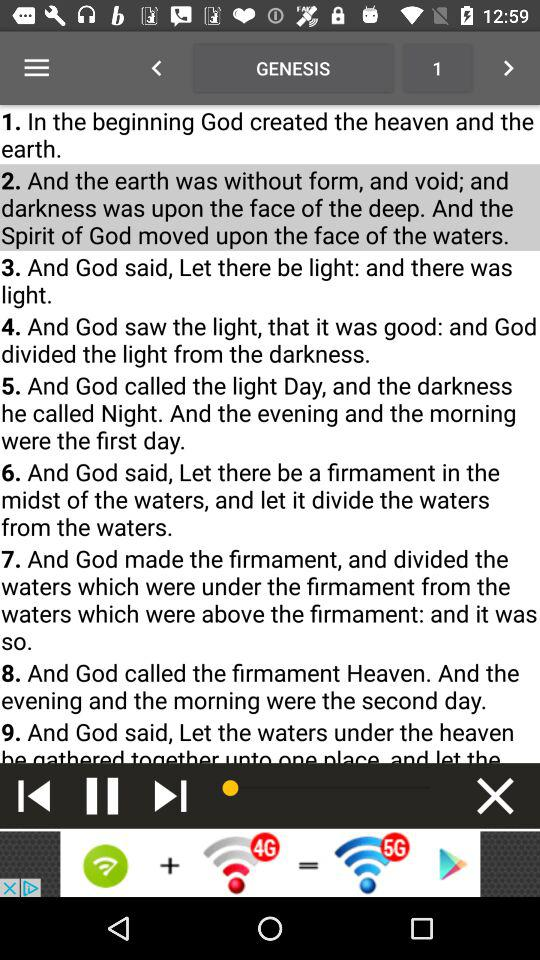Which track is currently playing? The currently playing track is "GENESIS 1". 